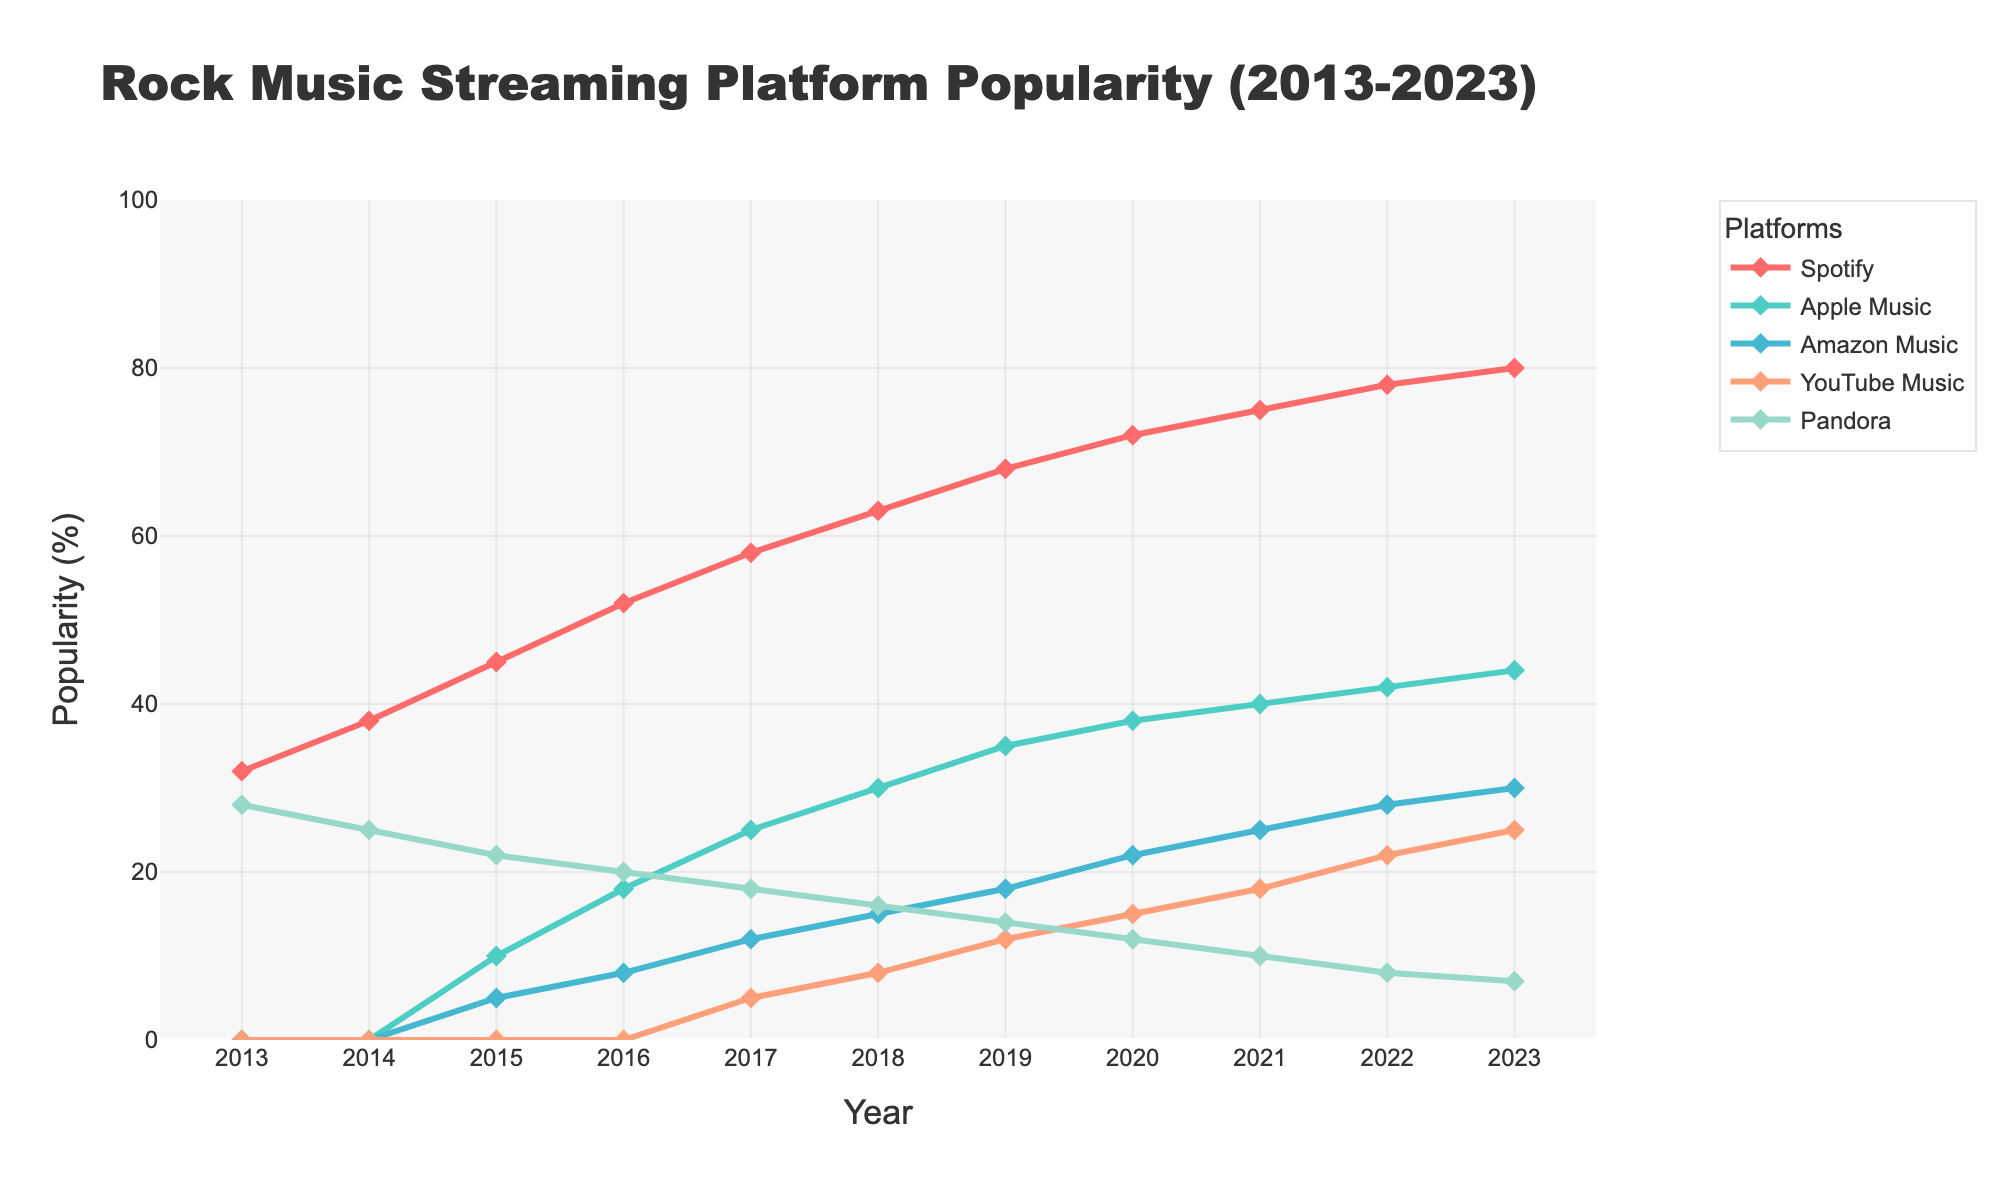What's the overall trend for Spotify's popularity from 2013 to 2023? By observing the line trend of Spotify, which shows a steady increase in popularity percentage each year from 32% in 2013 to 80% in 2023. This indicates a consistent upward trend.
Answer: Upward trend Which platform had the highest popularity in 2013? By looking at the starting points of each line, Pandora had the highest popularity in 2013 at 28%.
Answer: Pandora Between 2016 and 2021, which platform experienced the greatest increase in popularity? By comparing the increase in each platform's popularity between 2016 and 2021: 
- Spotify: from 52% to 75% (23% increase)
- Apple Music: from 18% to 40% (22% increase)
- Amazon Music: from 8% to 25% (17% increase)
- YouTube Music: from 0% to 18% (18% increase)
- Pandora: from 20% to 10% (-10% decrease)
Spotify had the greatest increase.
Answer: Spotify In which year did YouTube Music begin to show in the graph and what was its popularity percentage at that time? By observing the lines, YouTube Music appears in 2017 with an initial popularity of 5%.
Answer: 2017, 5% What is the difference in popularity between Apple Music and Amazon Music in 2023? By comparing the popularity percentages for Apple Music and Amazon Music in 2023:
- Apple Music: 44%
- Amazon Music: 30%
The difference is 44% - 30% = 14%.
Answer: 14% At what year did Spotify first surpass 50% in popularity? By looking at the point where the Spotify line crosses the 50% mark, which occurs in 2016.
Answer: 2016 Which platform has shown the most stable popularity trend over the years? By observing the lines, Pandora shows the most stable trend as it only gradually decreases from 28% in 2013 to 7% in 2023, unlike other platforms with steeper increases or more variability.
Answer: Pandora How did the popularity of Amazon Music change from 2015 to 2023? By observing the Amazon Music line, its popularity increased from 5% in 2015 to 30% in 2023, showing a steady upward trend.
Answer: Increased What's the total increase in popularity of YouTube Music from 2017 to 2023? By calculating the difference in popularity of YouTube Music from 2017 (5%) to 2023 (25%):
25% - 5% = 20%.
Answer: 20% How does the popularity of Pandora in 2019 compare to its popularity in 2023? By comparing the popularity percentages:
- 2019: 14%
- 2023: 7%
Pandora's popularity decreased by 7%.
Answer: Decreased by 7% 